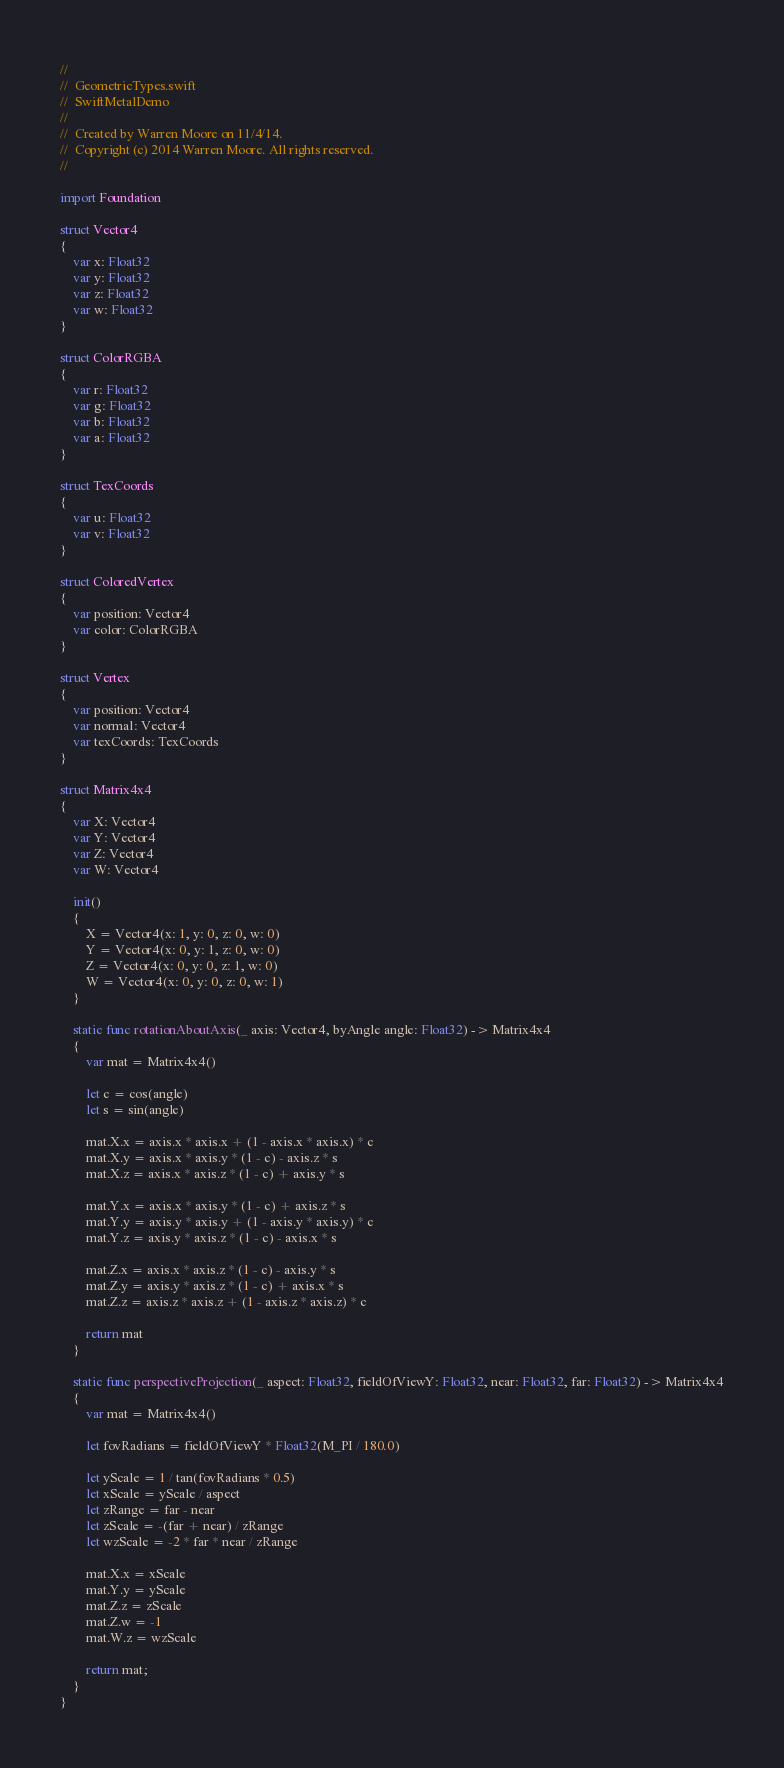<code> <loc_0><loc_0><loc_500><loc_500><_Swift_>//
//  GeometricTypes.swift
//  SwiftMetalDemo
//
//  Created by Warren Moore on 11/4/14.
//  Copyright (c) 2014 Warren Moore. All rights reserved.
//

import Foundation

struct Vector4
{
    var x: Float32
    var y: Float32
    var z: Float32
    var w: Float32
}

struct ColorRGBA
{
    var r: Float32
    var g: Float32
    var b: Float32
    var a: Float32
}

struct TexCoords
{
    var u: Float32
    var v: Float32
}

struct ColoredVertex
{
    var position: Vector4
    var color: ColorRGBA
}

struct Vertex
{
    var position: Vector4
    var normal: Vector4
    var texCoords: TexCoords
}

struct Matrix4x4
{
    var X: Vector4
    var Y: Vector4
    var Z: Vector4
    var W: Vector4

    init()
    {
        X = Vector4(x: 1, y: 0, z: 0, w: 0)
        Y = Vector4(x: 0, y: 1, z: 0, w: 0)
        Z = Vector4(x: 0, y: 0, z: 1, w: 0)
        W = Vector4(x: 0, y: 0, z: 0, w: 1)
    }
    
    static func rotationAboutAxis(_ axis: Vector4, byAngle angle: Float32) -> Matrix4x4
    {
        var mat = Matrix4x4()
        
        let c = cos(angle)
        let s = sin(angle)

        mat.X.x = axis.x * axis.x + (1 - axis.x * axis.x) * c
        mat.X.y = axis.x * axis.y * (1 - c) - axis.z * s
        mat.X.z = axis.x * axis.z * (1 - c) + axis.y * s

        mat.Y.x = axis.x * axis.y * (1 - c) + axis.z * s
        mat.Y.y = axis.y * axis.y + (1 - axis.y * axis.y) * c
        mat.Y.z = axis.y * axis.z * (1 - c) - axis.x * s

        mat.Z.x = axis.x * axis.z * (1 - c) - axis.y * s
        mat.Z.y = axis.y * axis.z * (1 - c) + axis.x * s
        mat.Z.z = axis.z * axis.z + (1 - axis.z * axis.z) * c

        return mat
    }
    
    static func perspectiveProjection(_ aspect: Float32, fieldOfViewY: Float32, near: Float32, far: Float32) -> Matrix4x4
    {
        var mat = Matrix4x4()
        
        let fovRadians = fieldOfViewY * Float32(M_PI / 180.0)

        let yScale = 1 / tan(fovRadians * 0.5)
        let xScale = yScale / aspect
        let zRange = far - near
        let zScale = -(far + near) / zRange
        let wzScale = -2 * far * near / zRange
        
        mat.X.x = xScale
        mat.Y.y = yScale
        mat.Z.z = zScale
        mat.Z.w = -1
        mat.W.z = wzScale

        return mat;
    }
}
</code> 